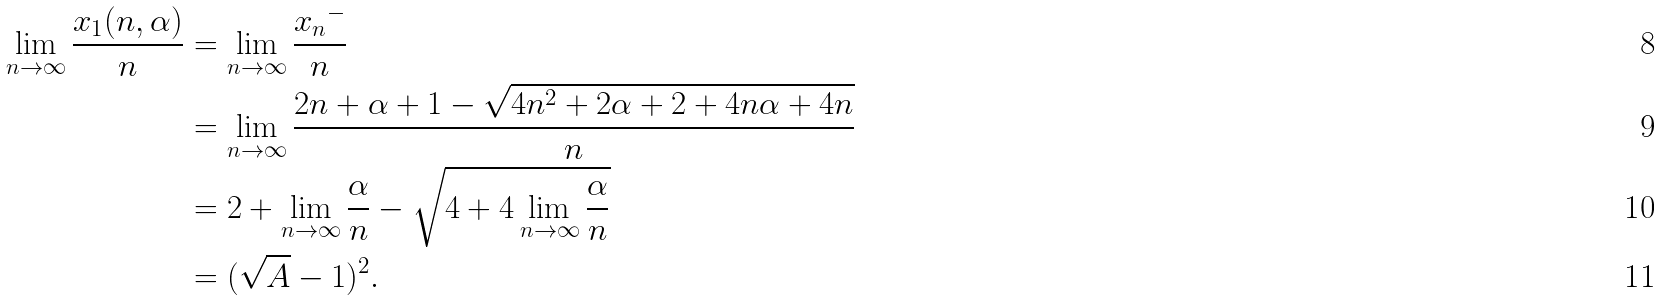<formula> <loc_0><loc_0><loc_500><loc_500>\lim _ { n \to \infty } \frac { x _ { 1 } ( n , \alpha ) } { n } & = \lim _ { n \to \infty } \frac { { x _ { n } } ^ { - } } { n } \\ & = \lim _ { n \to \infty } \frac { 2 n + \alpha + 1 - \sqrt { 4 n ^ { 2 } + 2 \alpha + 2 + 4 n \alpha + 4 n } } { n } \\ & = 2 + \lim _ { n \to \infty } \frac { \alpha } { n } - \sqrt { 4 + 4 \lim _ { n \to \infty } \frac { \alpha } { n } } \\ & = ( \sqrt { A } - 1 ) ^ { 2 } .</formula> 